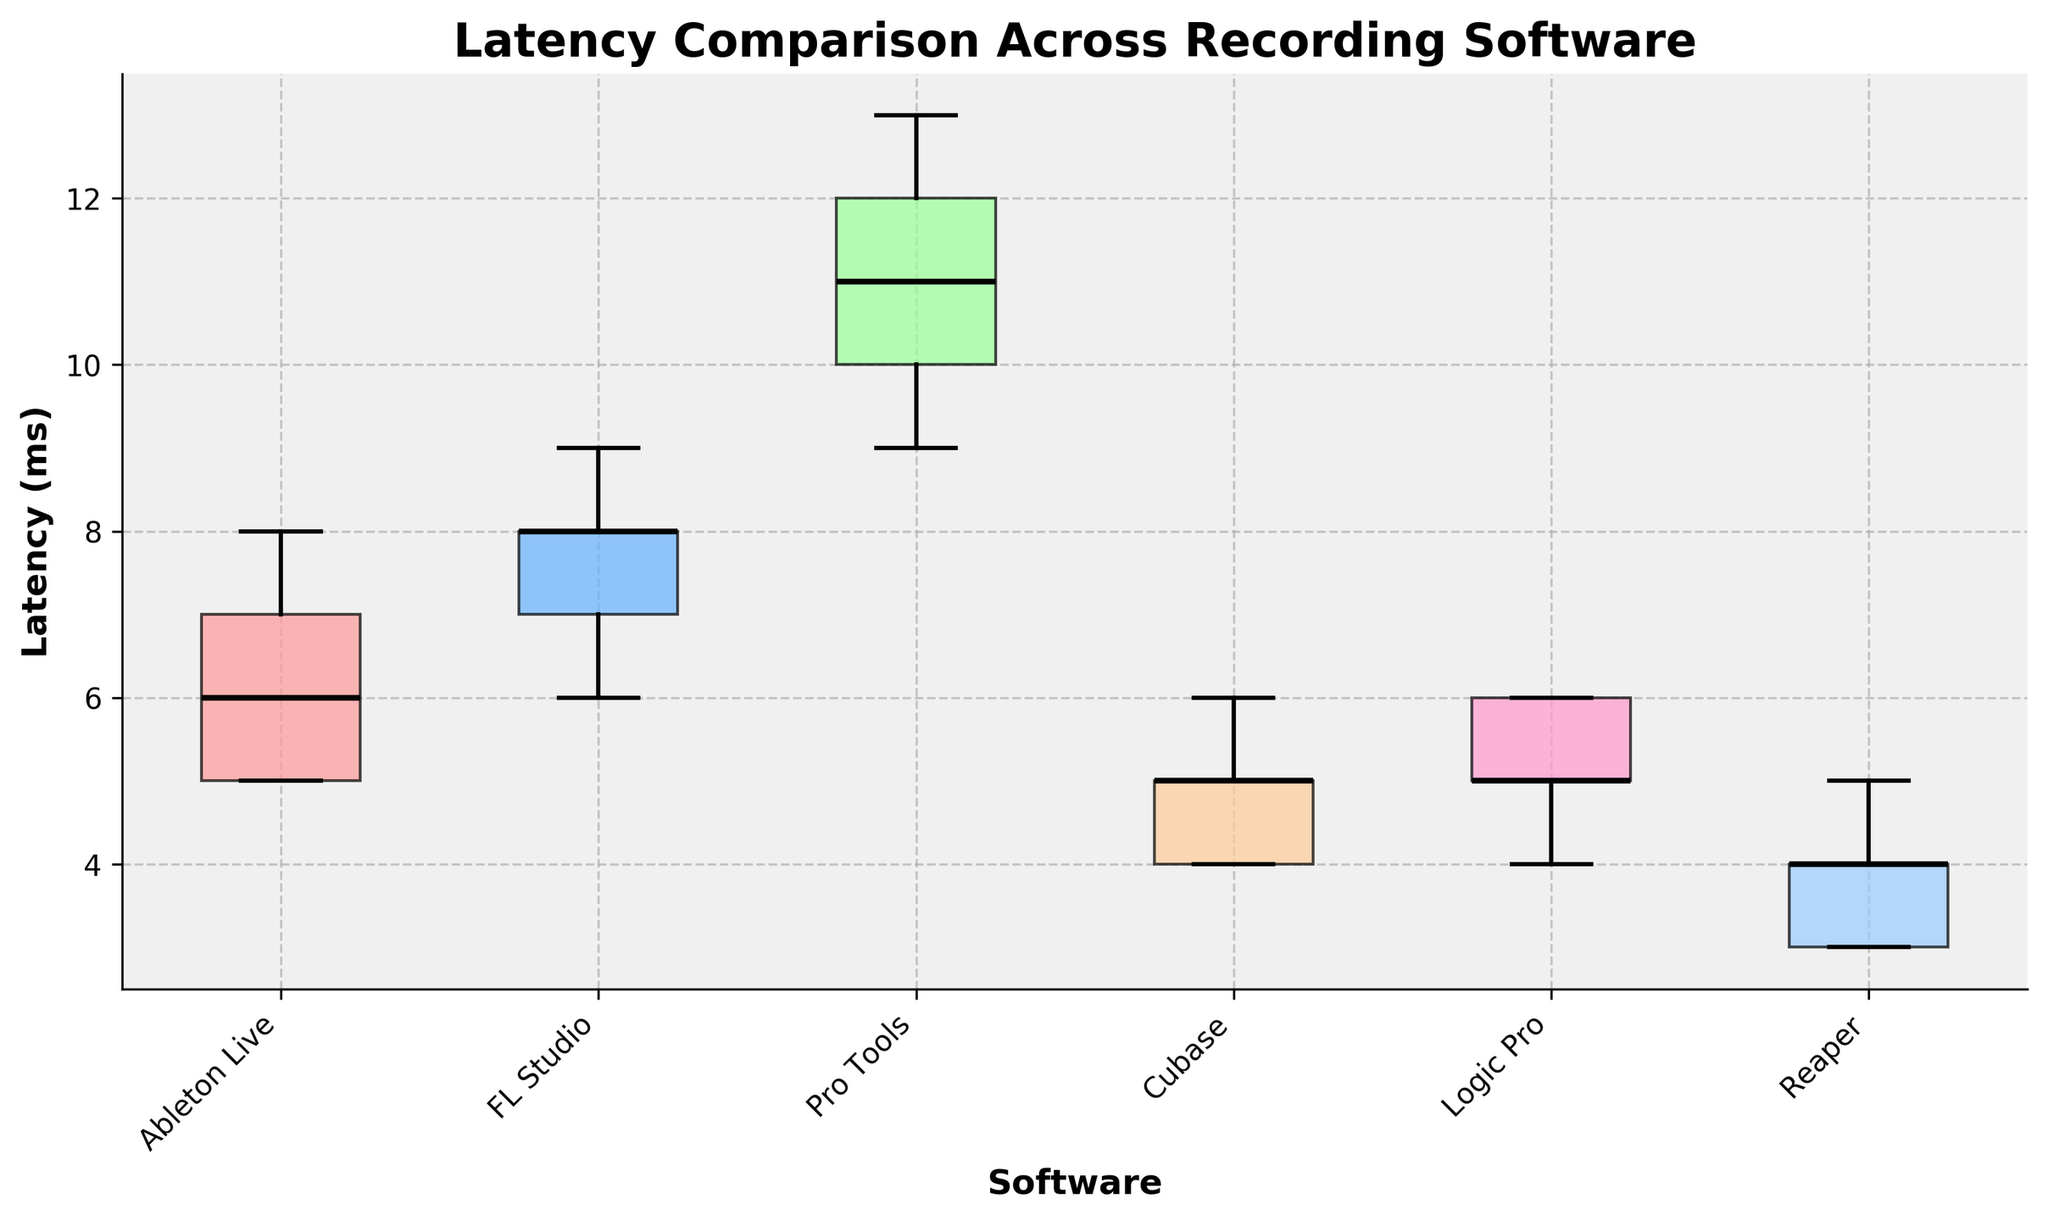What is the title of the figure? The title is directly displayed at the top of the figure in larger and bold font.
Answer: Latency Comparison Across Recording Software Which software has the lowest median latency? The median latency is represented by the black line inside each box. The lowest median line falls inside the box for Reaper.
Answer: Reaper What is the range of latencies for Ableton Live? The range of latencies can be determined by looking at the top and bottom points of the whiskers for Ableton Live.
Answer: 5 to 8 ms How does the latency of Cubase compare with FL Studio? We compare the median lines, which indicates that Cubase's median latency is lower than FL Studio's. We also observe the interquartile ranges and whiskers for overall variability.
Answer: Cubase has lower and less variable latency Which software has the smallest interquartile range (IQR)? The IQR is the difference between the top and bottom edges of the box. The smallest IQR is observed in Logic Pro's box.
Answer: Logic Pro Which software shows outlier(s) if any? Outliers appear as points outside the whiskers. No points lie outside the whiskers for any software in the figure, indicating no outliers.
Answer: None What is the upper whisker value for Pro Tools? The upper whisker is the top line extending from the box, for Pro Tools, this appears to be at 6 ms.
Answer: 6 ms Rank the software from the smallest to the largest median latency. We observe the black median lines within each box plot from lowest to highest. Reaper < Logic Pro < Pro Tools < Ableton Live < Cubase < FL Studio
Answer: Reaper, Logic Pro, Pro Tools, Ableton Live, Cubase, FL Studio Which software has the highest variability in latency? The variability can be inferred by the overall height of the box and whiskers. FL Studio has the largest overall spread indicating the highest variability.
Answer: FL Studio 